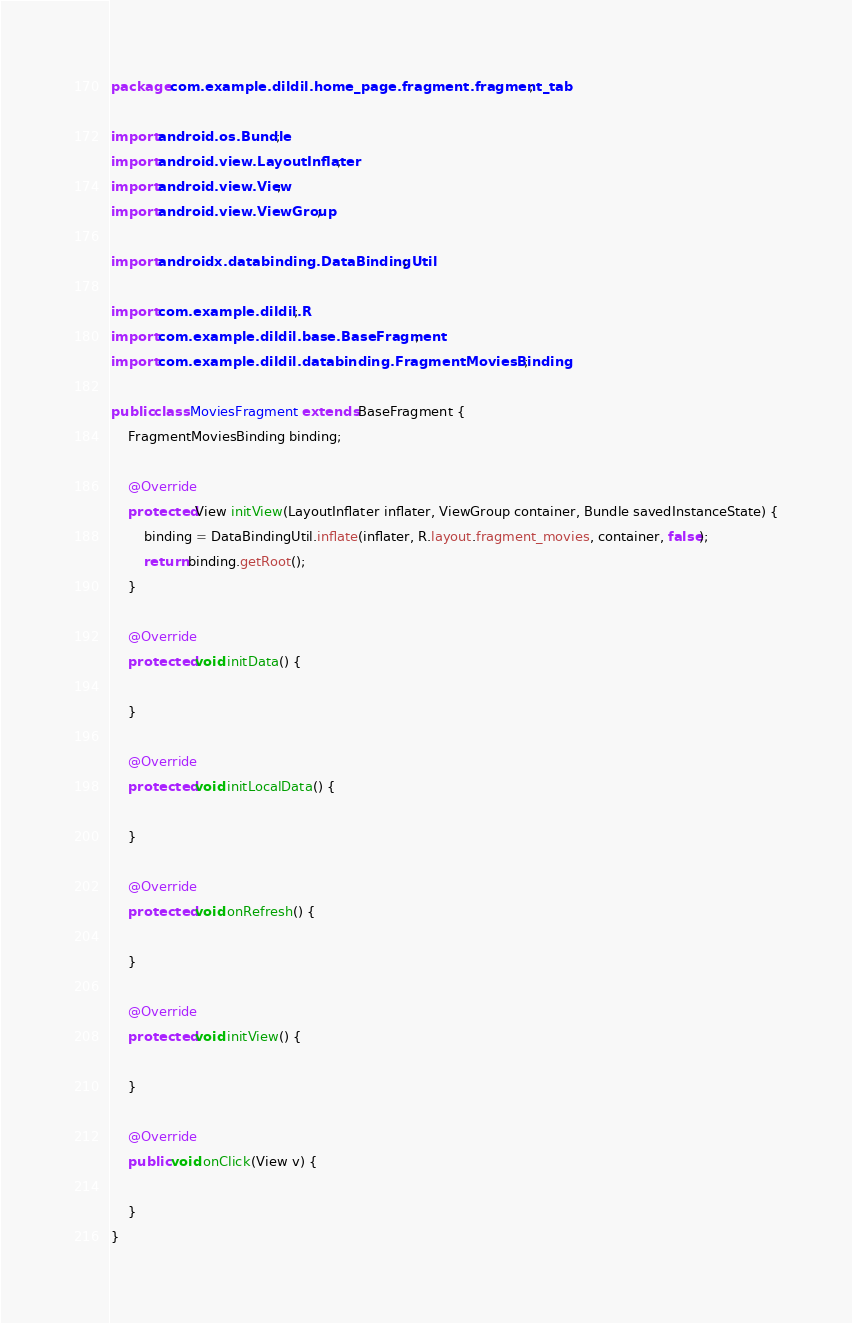<code> <loc_0><loc_0><loc_500><loc_500><_Java_>package com.example.dildil.home_page.fragment.fragment_tab;

import android.os.Bundle;
import android.view.LayoutInflater;
import android.view.View;
import android.view.ViewGroup;

import androidx.databinding.DataBindingUtil;

import com.example.dildil.R;
import com.example.dildil.base.BaseFragment;
import com.example.dildil.databinding.FragmentMoviesBinding;

public class MoviesFragment extends BaseFragment {
    FragmentMoviesBinding binding;

    @Override
    protected View initView(LayoutInflater inflater, ViewGroup container, Bundle savedInstanceState) {
        binding = DataBindingUtil.inflate(inflater, R.layout.fragment_movies, container, false);
        return binding.getRoot();
    }

    @Override
    protected void initData() {

    }

    @Override
    protected void initLocalData() {

    }

    @Override
    protected void onRefresh() {

    }

    @Override
    protected void initView() {

    }

    @Override
    public void onClick(View v) {

    }
}
</code> 